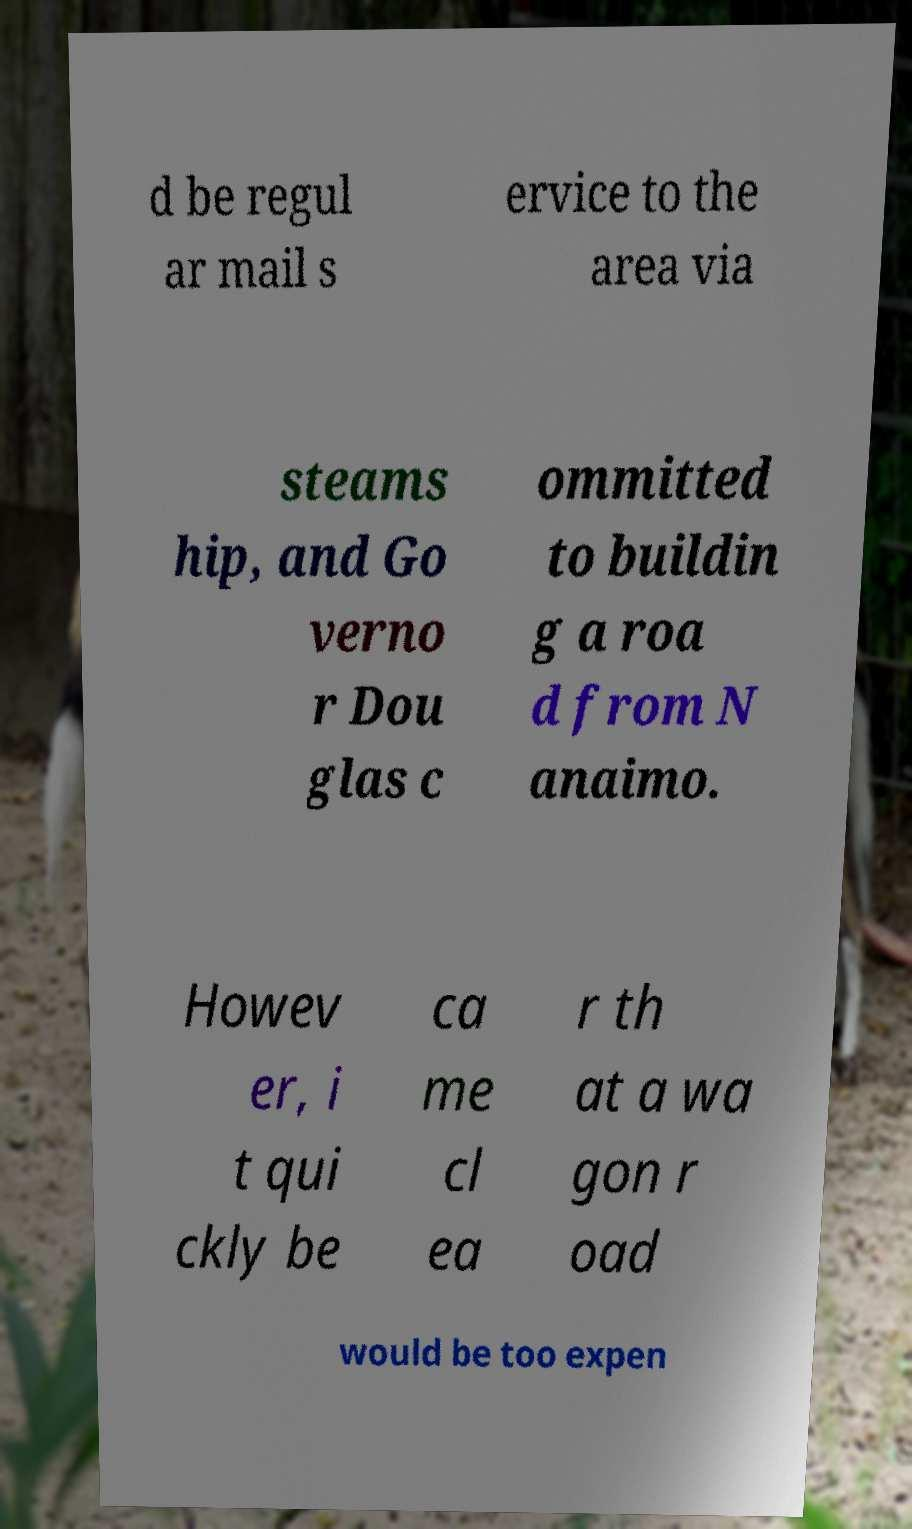Could you extract and type out the text from this image? d be regul ar mail s ervice to the area via steams hip, and Go verno r Dou glas c ommitted to buildin g a roa d from N anaimo. Howev er, i t qui ckly be ca me cl ea r th at a wa gon r oad would be too expen 